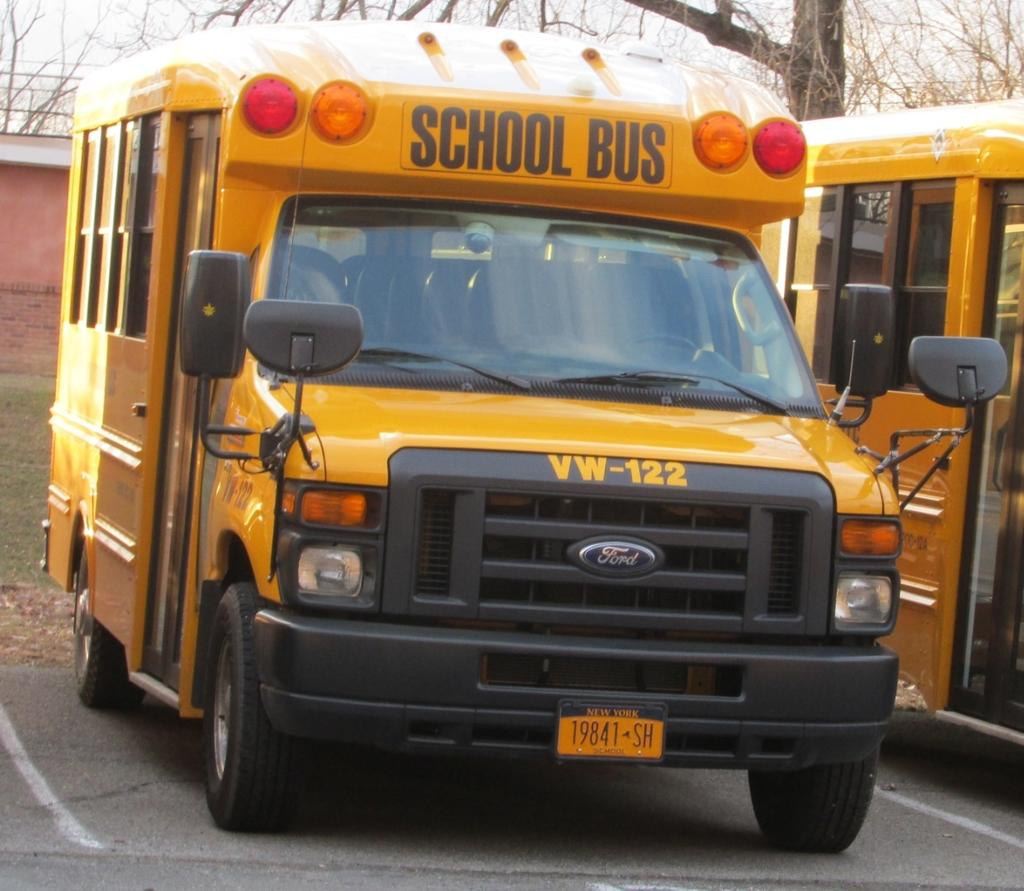<image>
Create a compact narrative representing the image presented. A school bus with New York State tags that says VW-122 on the front. 